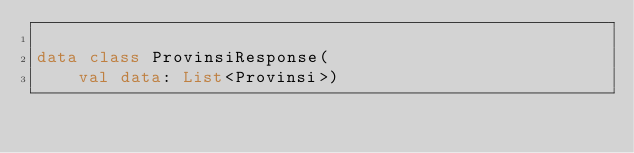Convert code to text. <code><loc_0><loc_0><loc_500><loc_500><_Kotlin_>
data class ProvinsiResponse(
    val data: List<Provinsi>)</code> 